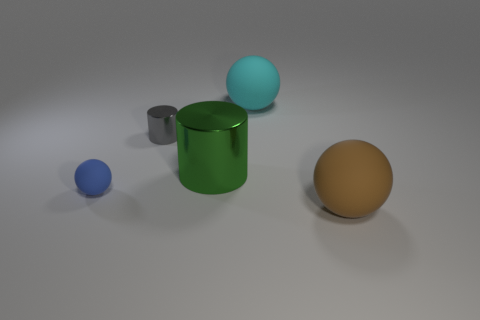What is the color of the small shiny object that is the same shape as the big green metallic object?
Offer a very short reply. Gray. There is a rubber object that is both in front of the gray cylinder and behind the big brown object; how big is it?
Your answer should be very brief. Small. Is the shape of the matte thing behind the big green metal cylinder the same as the tiny object that is behind the tiny matte thing?
Make the answer very short. No. How many green cylinders are the same material as the large cyan thing?
Keep it short and to the point. 0. There is a thing that is to the right of the blue rubber sphere and to the left of the green metallic cylinder; what shape is it?
Your answer should be very brief. Cylinder. Does the cylinder on the right side of the gray metal cylinder have the same material as the blue thing?
Your answer should be very brief. No. The metallic cylinder that is the same size as the blue object is what color?
Provide a short and direct response. Gray. There is a brown ball that is made of the same material as the large cyan thing; what size is it?
Make the answer very short. Large. How many other things are there of the same size as the blue rubber object?
Your answer should be very brief. 1. There is a cyan object that is right of the green metallic cylinder; what material is it?
Provide a short and direct response. Rubber. 